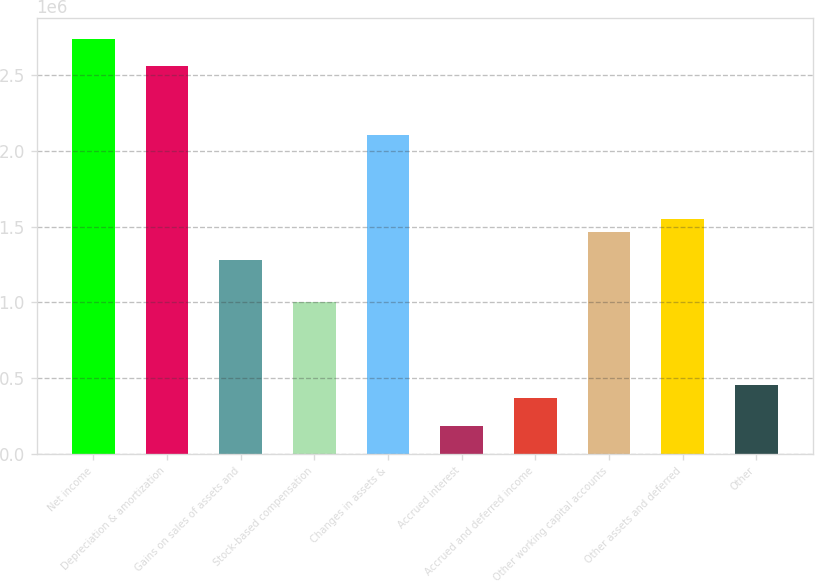Convert chart. <chart><loc_0><loc_0><loc_500><loc_500><bar_chart><fcel>Net income<fcel>Depreciation & amortization<fcel>Gains on sales of assets and<fcel>Stock-based compensation<fcel>Changes in assets &<fcel>Accrued interest<fcel>Accrued and deferred income<fcel>Other working capital accounts<fcel>Other assets and deferred<fcel>Other<nl><fcel>2.74049e+06<fcel>2.55779e+06<fcel>1.2789e+06<fcel>1.00485e+06<fcel>2.10105e+06<fcel>182703<fcel>365402<fcel>1.4616e+06<fcel>1.55295e+06<fcel>456752<nl></chart> 